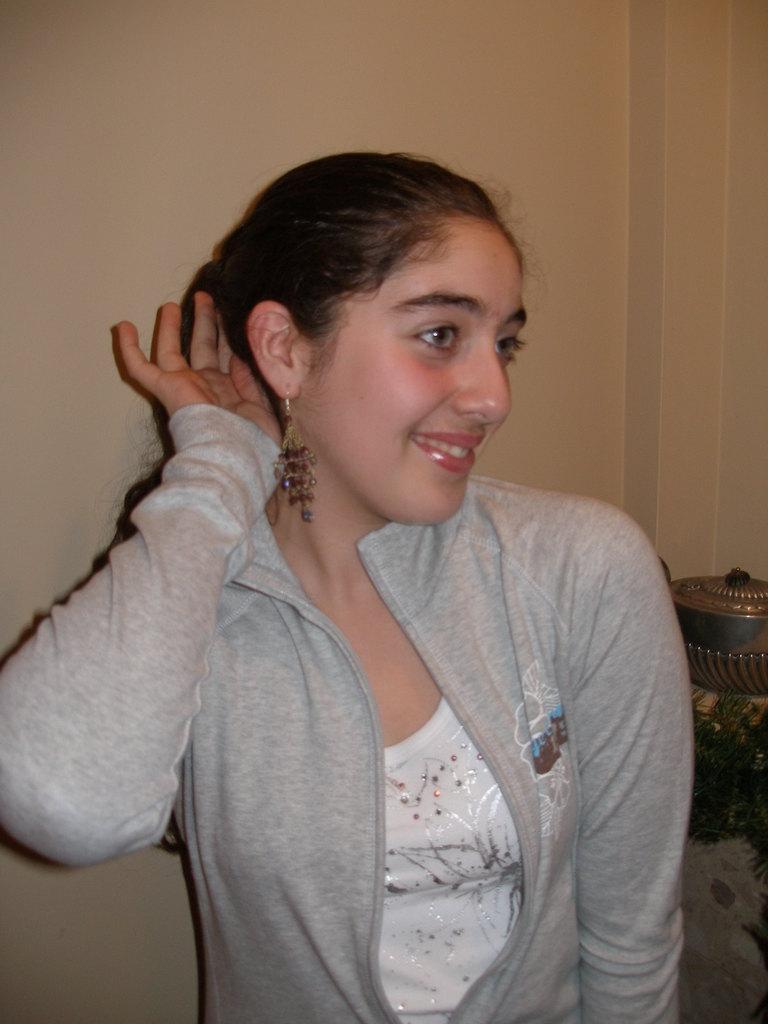Can you describe this image briefly? In this image we can see a woman. On the backside we can see some objects and a wall. 